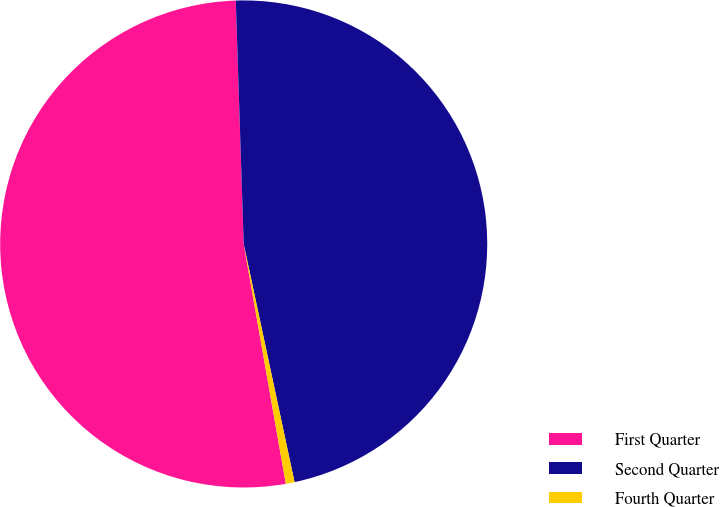Convert chart to OTSL. <chart><loc_0><loc_0><loc_500><loc_500><pie_chart><fcel>First Quarter<fcel>Second Quarter<fcel>Fourth Quarter<nl><fcel>52.25%<fcel>47.17%<fcel>0.58%<nl></chart> 